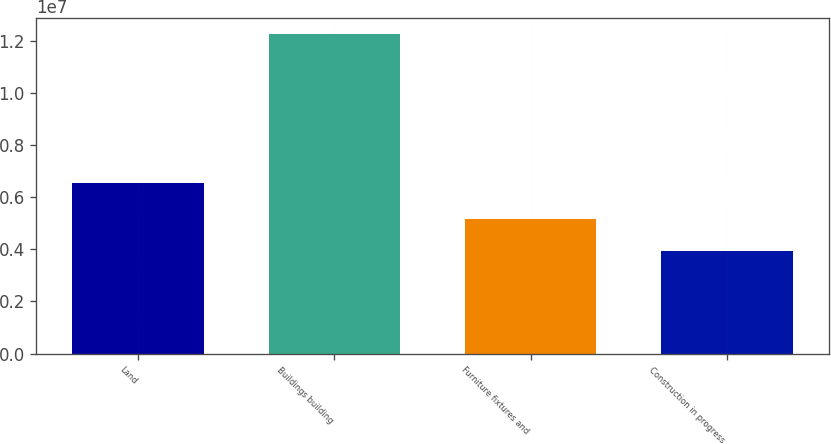<chart> <loc_0><loc_0><loc_500><loc_500><bar_chart><fcel>Land<fcel>Buildings building<fcel>Furniture fixtures and<fcel>Construction in progress<nl><fcel>6.5317e+06<fcel>1.2246e+07<fcel>5.15736e+06<fcel>3.95064e+06<nl></chart> 